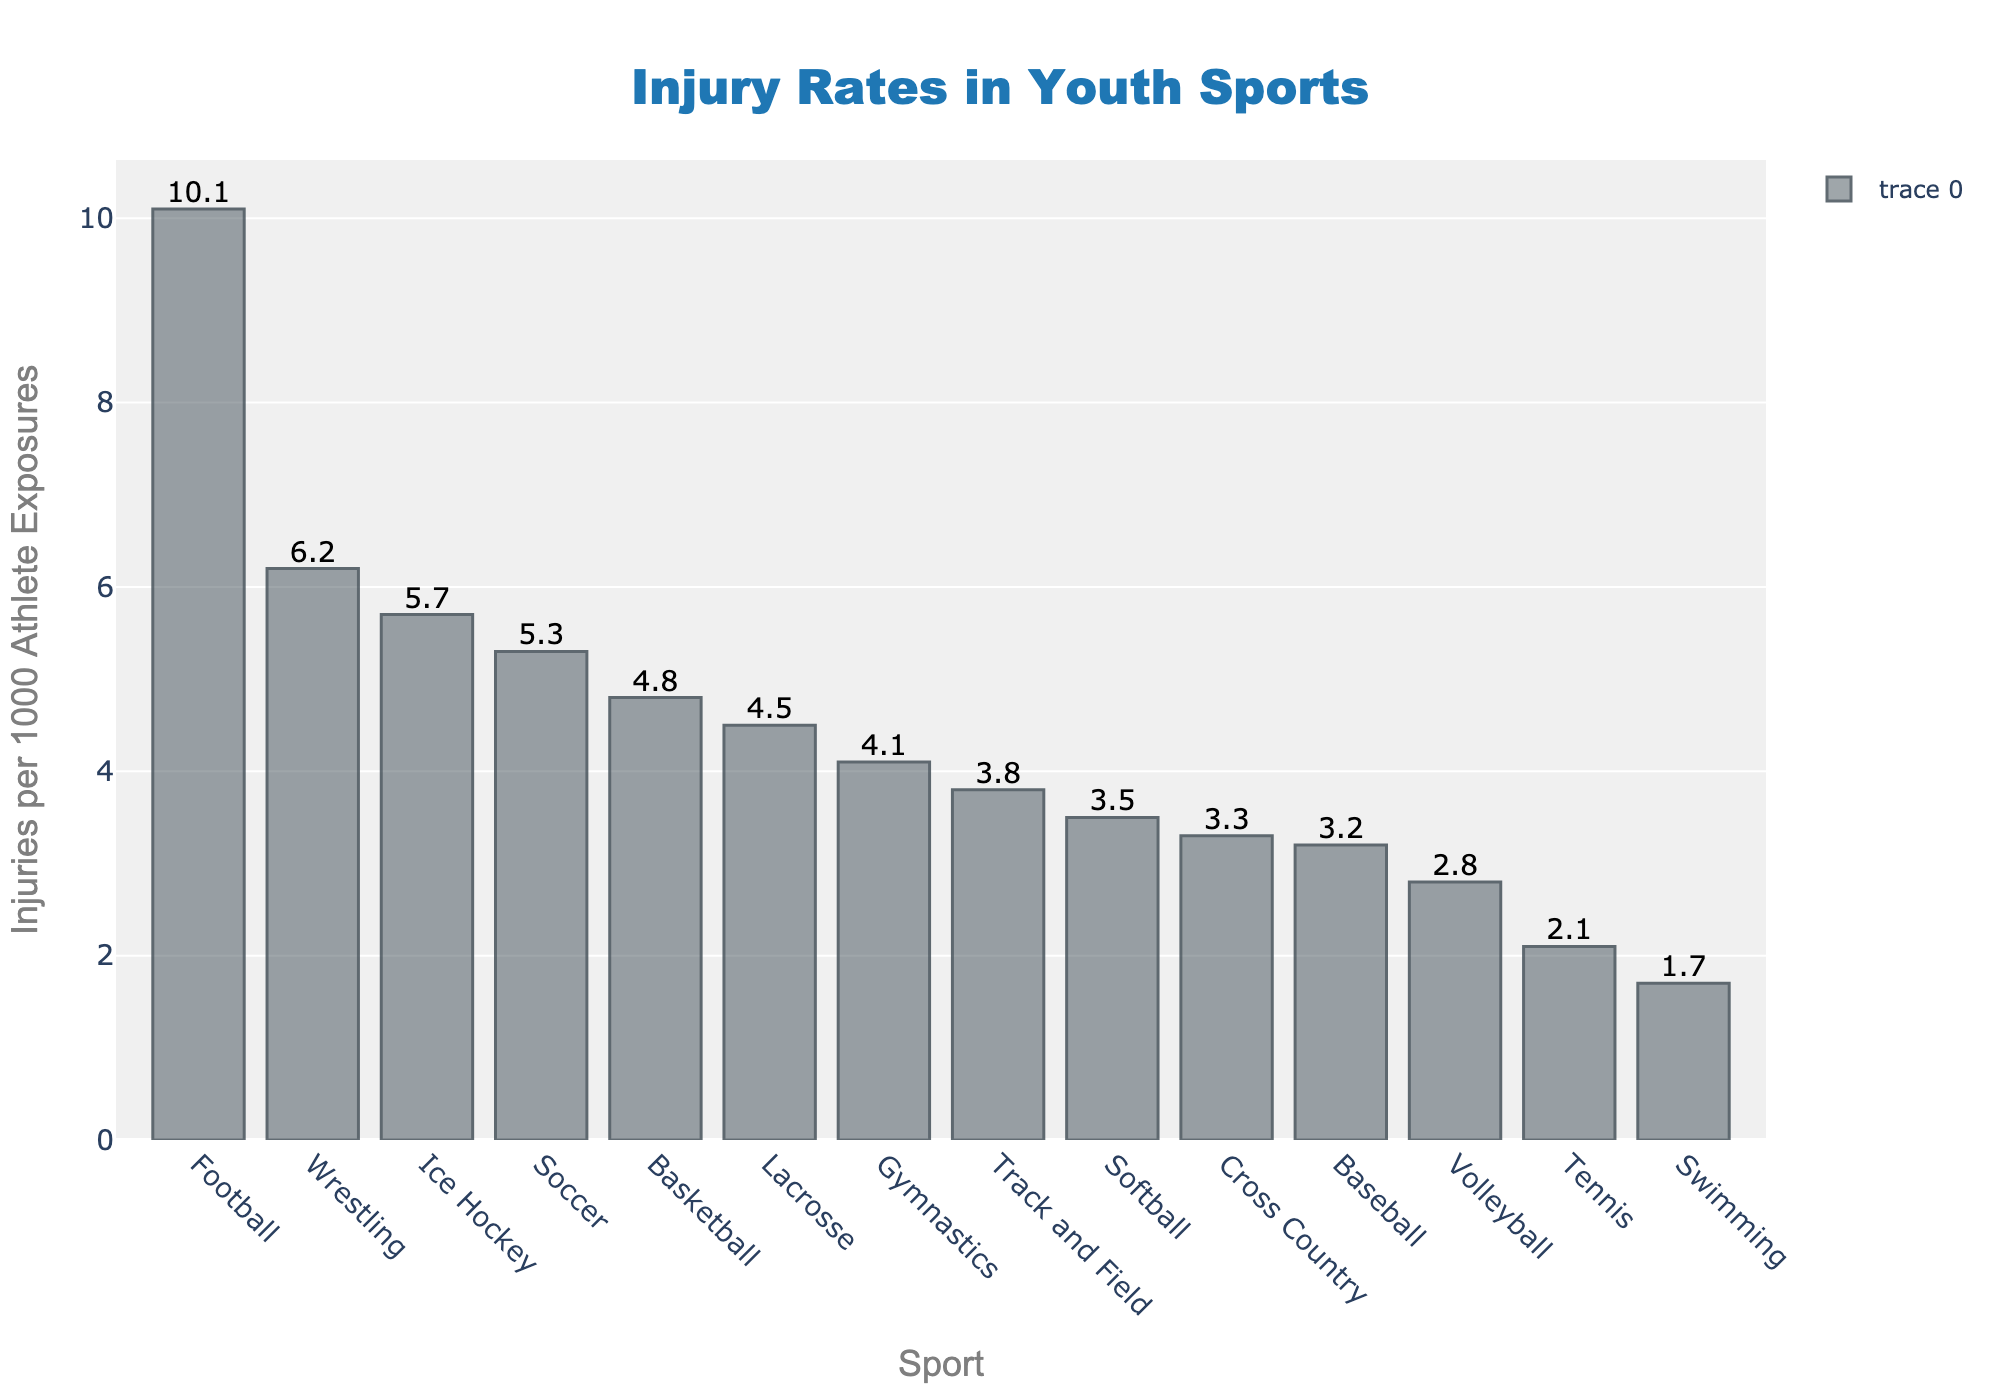Which sport has the highest injury rate? To determine which sport has the highest injury rate, locate the tallest bar in the bar chart. The highest bar represents Football with an injury rate of 10.1 per 1000 athlete exposures.
Answer: Football How does the injury rate for Soccer compare to Basketball? To compare the injury rates for Soccer and Basketball, find the heights of the corresponding bars. Soccer has an injury rate of 5.3, while Basketball has an injury rate of 4.8. Soccer has a higher injury rate than Basketball.
Answer: Soccer has a higher injury rate What is the difference in injury rates between Wrestling and Swimming? Locate the bars for Wrestling and Swimming and note their heights. Wrestling has an injury rate of 6.2, while Swimming has an injury rate of 1.7. Subtract Swimming's injury rate from Wrestling's to find the difference: 6.2 - 1.7 = 4.5.
Answer: 4.5 Which sport has the lowest injury rate? Identify the shortest bar in the bar chart, which indicates the sport with the lowest injury rate. Swimming has the shortest bar, representing an injury rate of 1.7 per 1000 athlete exposures.
Answer: Swimming What is the median injury rate of the sports listed? To find the median injury rate, arrange the injury rates in ascending order: 1.7, 2.1, 2.8, 3.2, 3.3, 3.5, 3.8, 4.1, 4.5, 4.8, 5.3, 5.7, 6.2, 10.1. The median is the middle value or the average of the two central values if the number of data points is even. With 14 sports, the median is the average of the 7th and 8th values: (3.8 + 4.1)/2 = 3.95.
Answer: 3.95 What is the combined injury rate of Baseball, Softball, and Cross Country? Locate the bars for Baseball, Softball, and Cross Country and add their injury rates: Baseball (3.2) + Softball (3.5) + Cross Country (3.3) = 10.0.
Answer: 10.0 Compare the injury rates of Ice Hockey and Lacrosse. Which sport has a higher injury rate? Find the heights of the bars for Ice Hockey and Lacrosse. Ice Hockey has an injury rate of 5.7, while Lacrosse has an injury rate of 4.5. Ice Hockey has a higher injury rate than Lacrosse.
Answer: Ice Hockey Which sport has an injury rate closest to the overall average injury rate of the sports listed? Calculate the average injury rate by summing all the injury rates and dividing by the number of sports: (10.1 + 5.3 + 4.8 + 6.2 + 5.7 + 4.5 + 3.2 + 3.5 + 2.8 + 4.1 + 3.8 + 1.7 + 2.1 + 3.3)/14 = 4.21. Identify the sport with an injury rate closest to 4.21, which is Gymnastics with an injury rate of 4.1.
Answer: Gymnastics What is the sum of the injury rates for Soccer, Basketball, and Volleyball? Find the bars for Soccer, Basketball, and Volleyball and add their injury rates: Soccer (5.3), Basketball (4.8), and Volleyball (2.8). The sum is 5.3 + 4.8 + 2.8 = 12.9.
Answer: 12.9 Which sports have an injury rate below 3.5 per 1000 athlete exposures? Identify the bars with heights below 3.5. These sports are Baseball (3.2), Volleyball (2.8), Swimming (1.7), and Tennis (2.1).
Answer: Baseball, Volleyball, Swimming, Tennis 